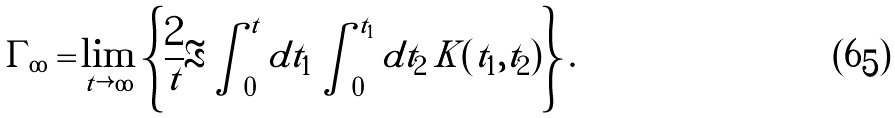<formula> <loc_0><loc_0><loc_500><loc_500>\Gamma _ { \infty } = & \lim _ { t \rightarrow \infty } \left \{ \frac { 2 } { t } \Re \int _ { 0 } ^ { t } d t _ { 1 } \int _ { 0 } ^ { t _ { 1 } } d t _ { 2 } \, K ( t _ { 1 } , t _ { 2 } ) \right \} .</formula> 